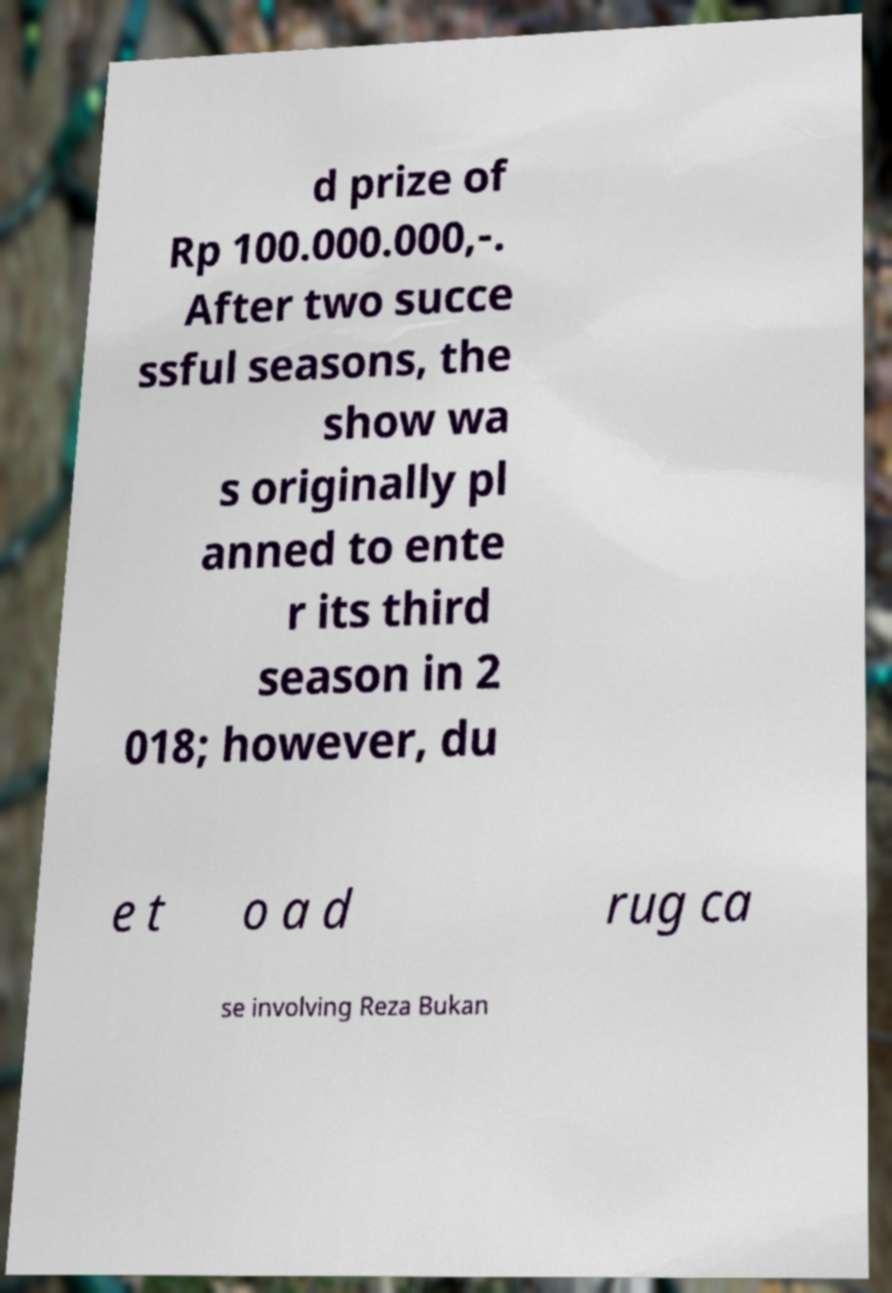Could you extract and type out the text from this image? d prize of Rp 100.000.000,-. After two succe ssful seasons, the show wa s originally pl anned to ente r its third season in 2 018; however, du e t o a d rug ca se involving Reza Bukan 